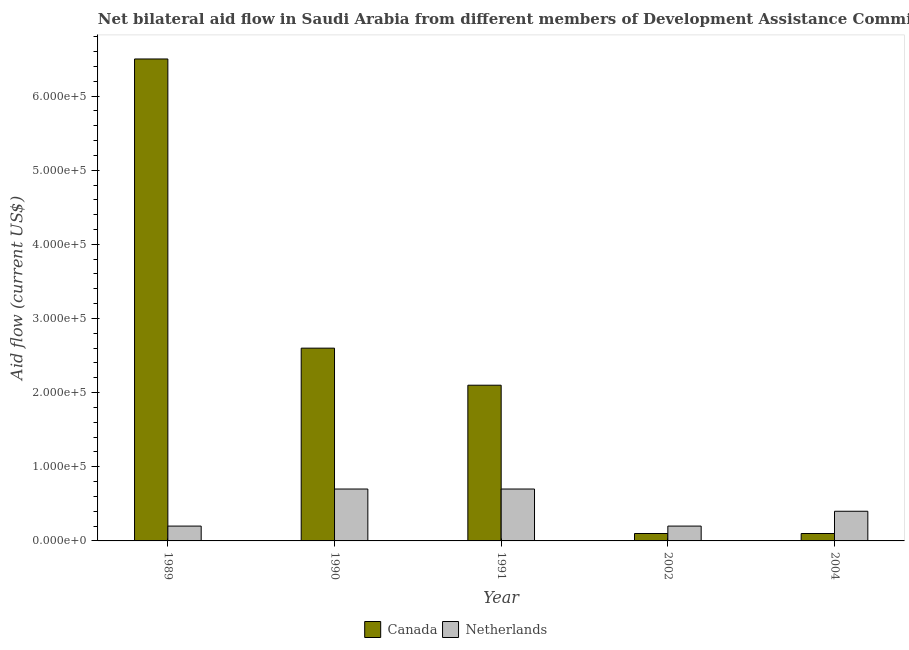How many different coloured bars are there?
Provide a succinct answer. 2. Are the number of bars on each tick of the X-axis equal?
Give a very brief answer. Yes. In how many cases, is the number of bars for a given year not equal to the number of legend labels?
Give a very brief answer. 0. What is the amount of aid given by canada in 1991?
Offer a very short reply. 2.10e+05. Across all years, what is the maximum amount of aid given by netherlands?
Offer a terse response. 7.00e+04. Across all years, what is the minimum amount of aid given by canada?
Keep it short and to the point. 10000. In which year was the amount of aid given by canada maximum?
Provide a succinct answer. 1989. What is the total amount of aid given by netherlands in the graph?
Provide a succinct answer. 2.20e+05. What is the difference between the amount of aid given by netherlands in 1989 and that in 1991?
Your answer should be very brief. -5.00e+04. What is the difference between the amount of aid given by netherlands in 1991 and the amount of aid given by canada in 2002?
Your answer should be very brief. 5.00e+04. What is the average amount of aid given by canada per year?
Make the answer very short. 2.28e+05. In the year 1990, what is the difference between the amount of aid given by canada and amount of aid given by netherlands?
Your response must be concise. 0. What is the difference between the highest and the lowest amount of aid given by netherlands?
Your answer should be compact. 5.00e+04. Is the sum of the amount of aid given by canada in 1990 and 2002 greater than the maximum amount of aid given by netherlands across all years?
Your response must be concise. No. What does the 1st bar from the right in 1991 represents?
Ensure brevity in your answer.  Netherlands. How many years are there in the graph?
Your answer should be very brief. 5. Are the values on the major ticks of Y-axis written in scientific E-notation?
Provide a short and direct response. Yes. Does the graph contain any zero values?
Provide a short and direct response. No. Does the graph contain grids?
Keep it short and to the point. No. What is the title of the graph?
Provide a short and direct response. Net bilateral aid flow in Saudi Arabia from different members of Development Assistance Committee. What is the label or title of the X-axis?
Give a very brief answer. Year. What is the label or title of the Y-axis?
Give a very brief answer. Aid flow (current US$). What is the Aid flow (current US$) of Canada in 1989?
Provide a short and direct response. 6.50e+05. What is the Aid flow (current US$) of Canada in 2002?
Offer a very short reply. 10000. What is the Aid flow (current US$) in Netherlands in 2002?
Your answer should be compact. 2.00e+04. What is the Aid flow (current US$) of Netherlands in 2004?
Keep it short and to the point. 4.00e+04. Across all years, what is the maximum Aid flow (current US$) of Canada?
Ensure brevity in your answer.  6.50e+05. Across all years, what is the minimum Aid flow (current US$) of Canada?
Ensure brevity in your answer.  10000. Across all years, what is the minimum Aid flow (current US$) of Netherlands?
Your answer should be compact. 2.00e+04. What is the total Aid flow (current US$) in Canada in the graph?
Offer a terse response. 1.14e+06. What is the difference between the Aid flow (current US$) in Netherlands in 1989 and that in 1991?
Keep it short and to the point. -5.00e+04. What is the difference between the Aid flow (current US$) in Canada in 1989 and that in 2002?
Keep it short and to the point. 6.40e+05. What is the difference between the Aid flow (current US$) of Netherlands in 1989 and that in 2002?
Offer a terse response. 0. What is the difference between the Aid flow (current US$) of Canada in 1989 and that in 2004?
Provide a succinct answer. 6.40e+05. What is the difference between the Aid flow (current US$) of Netherlands in 1989 and that in 2004?
Make the answer very short. -2.00e+04. What is the difference between the Aid flow (current US$) in Netherlands in 1990 and that in 2002?
Make the answer very short. 5.00e+04. What is the difference between the Aid flow (current US$) of Canada in 1990 and that in 2004?
Provide a succinct answer. 2.50e+05. What is the difference between the Aid flow (current US$) in Netherlands in 1991 and that in 2002?
Your answer should be compact. 5.00e+04. What is the difference between the Aid flow (current US$) of Netherlands in 2002 and that in 2004?
Offer a very short reply. -2.00e+04. What is the difference between the Aid flow (current US$) in Canada in 1989 and the Aid flow (current US$) in Netherlands in 1990?
Make the answer very short. 5.80e+05. What is the difference between the Aid flow (current US$) in Canada in 1989 and the Aid flow (current US$) in Netherlands in 1991?
Your answer should be very brief. 5.80e+05. What is the difference between the Aid flow (current US$) in Canada in 1989 and the Aid flow (current US$) in Netherlands in 2002?
Make the answer very short. 6.30e+05. What is the difference between the Aid flow (current US$) in Canada in 1989 and the Aid flow (current US$) in Netherlands in 2004?
Your response must be concise. 6.10e+05. What is the difference between the Aid flow (current US$) in Canada in 1990 and the Aid flow (current US$) in Netherlands in 1991?
Provide a short and direct response. 1.90e+05. What is the difference between the Aid flow (current US$) in Canada in 1991 and the Aid flow (current US$) in Netherlands in 2002?
Provide a succinct answer. 1.90e+05. What is the average Aid flow (current US$) in Canada per year?
Ensure brevity in your answer.  2.28e+05. What is the average Aid flow (current US$) in Netherlands per year?
Ensure brevity in your answer.  4.40e+04. In the year 1989, what is the difference between the Aid flow (current US$) of Canada and Aid flow (current US$) of Netherlands?
Your answer should be very brief. 6.30e+05. In the year 1991, what is the difference between the Aid flow (current US$) of Canada and Aid flow (current US$) of Netherlands?
Make the answer very short. 1.40e+05. In the year 2002, what is the difference between the Aid flow (current US$) of Canada and Aid flow (current US$) of Netherlands?
Make the answer very short. -10000. What is the ratio of the Aid flow (current US$) of Netherlands in 1989 to that in 1990?
Your answer should be very brief. 0.29. What is the ratio of the Aid flow (current US$) of Canada in 1989 to that in 1991?
Keep it short and to the point. 3.1. What is the ratio of the Aid flow (current US$) in Netherlands in 1989 to that in 1991?
Keep it short and to the point. 0.29. What is the ratio of the Aid flow (current US$) in Canada in 1990 to that in 1991?
Give a very brief answer. 1.24. What is the ratio of the Aid flow (current US$) of Canada in 1990 to that in 2002?
Your answer should be compact. 26. What is the ratio of the Aid flow (current US$) in Netherlands in 1990 to that in 2002?
Offer a terse response. 3.5. What is the ratio of the Aid flow (current US$) in Netherlands in 1990 to that in 2004?
Offer a very short reply. 1.75. What is the ratio of the Aid flow (current US$) in Canada in 1991 to that in 2004?
Provide a succinct answer. 21. What is the difference between the highest and the lowest Aid flow (current US$) in Canada?
Offer a very short reply. 6.40e+05. 